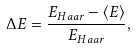Convert formula to latex. <formula><loc_0><loc_0><loc_500><loc_500>\Delta E = \frac { E _ { H a a r } - \langle E \rangle } { E _ { H a a r } } ,</formula> 